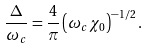<formula> <loc_0><loc_0><loc_500><loc_500>\frac { \Delta } { \omega _ { c } } = \frac { 4 } { \pi } \left ( \omega _ { c } \chi _ { 0 } \right ) ^ { - 1 / 2 } .</formula> 